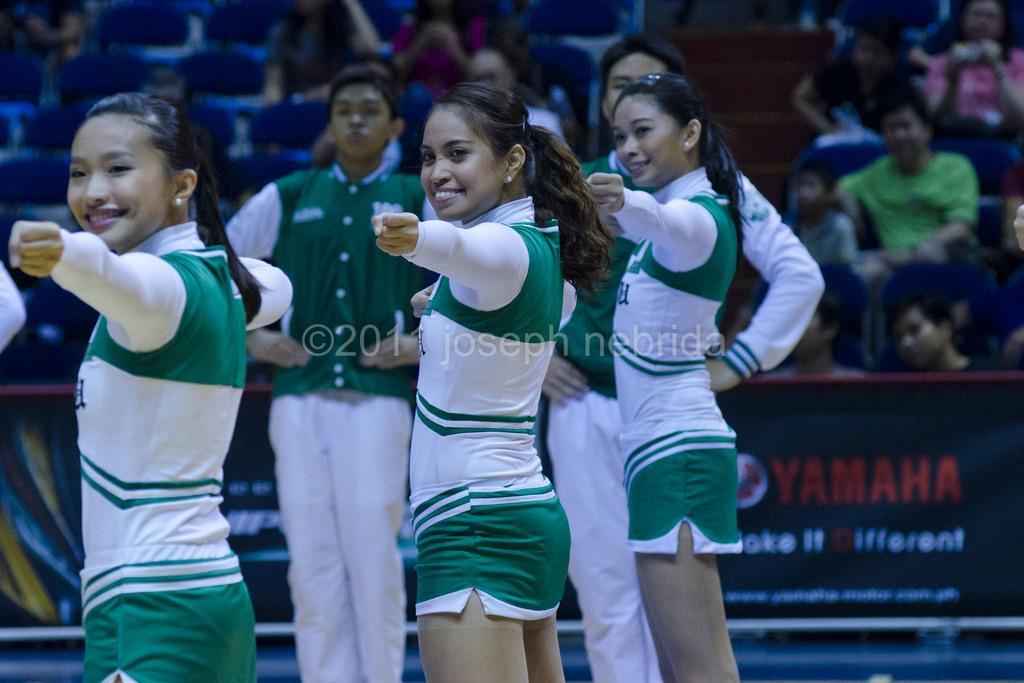How would you summarize this image in a sentence or two? In this image there are three persons standing and smiling ,and in the background there are two persons standing, group of people sitting on the chairs, board. 